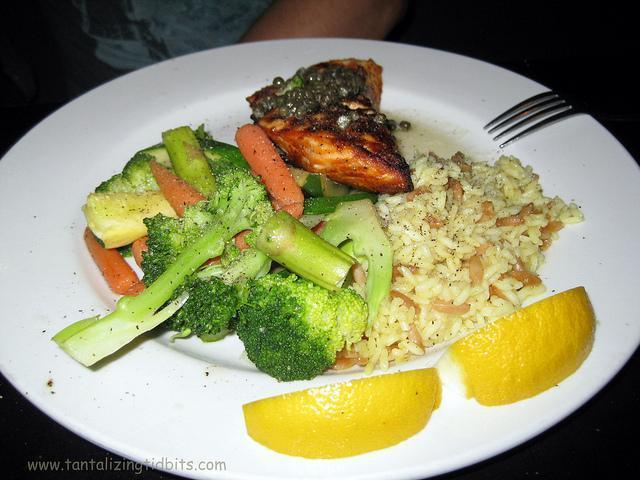How many prongs does the fork have?
Give a very brief answer. 4. How many different vegetables does this dish contain?
Give a very brief answer. 3. How many forks can be seen?
Give a very brief answer. 1. 